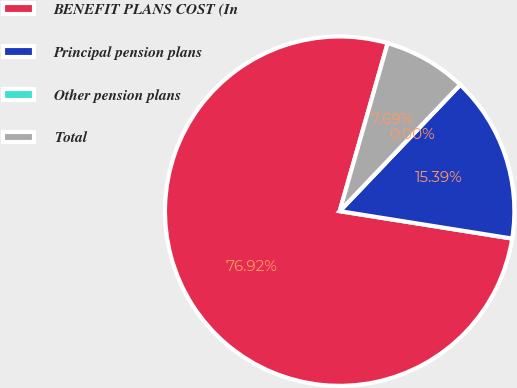Convert chart. <chart><loc_0><loc_0><loc_500><loc_500><pie_chart><fcel>BENEFIT PLANS COST (In<fcel>Principal pension plans<fcel>Other pension plans<fcel>Total<nl><fcel>76.92%<fcel>15.39%<fcel>0.0%<fcel>7.69%<nl></chart> 